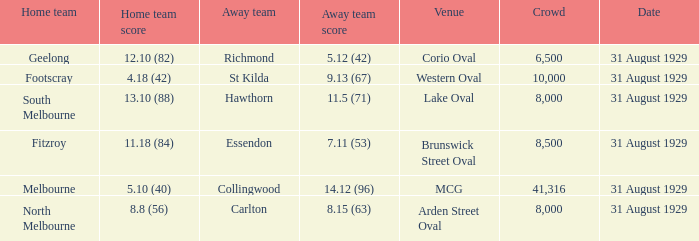What was the date of the game in which carlton participated as the away team? 31 August 1929. 